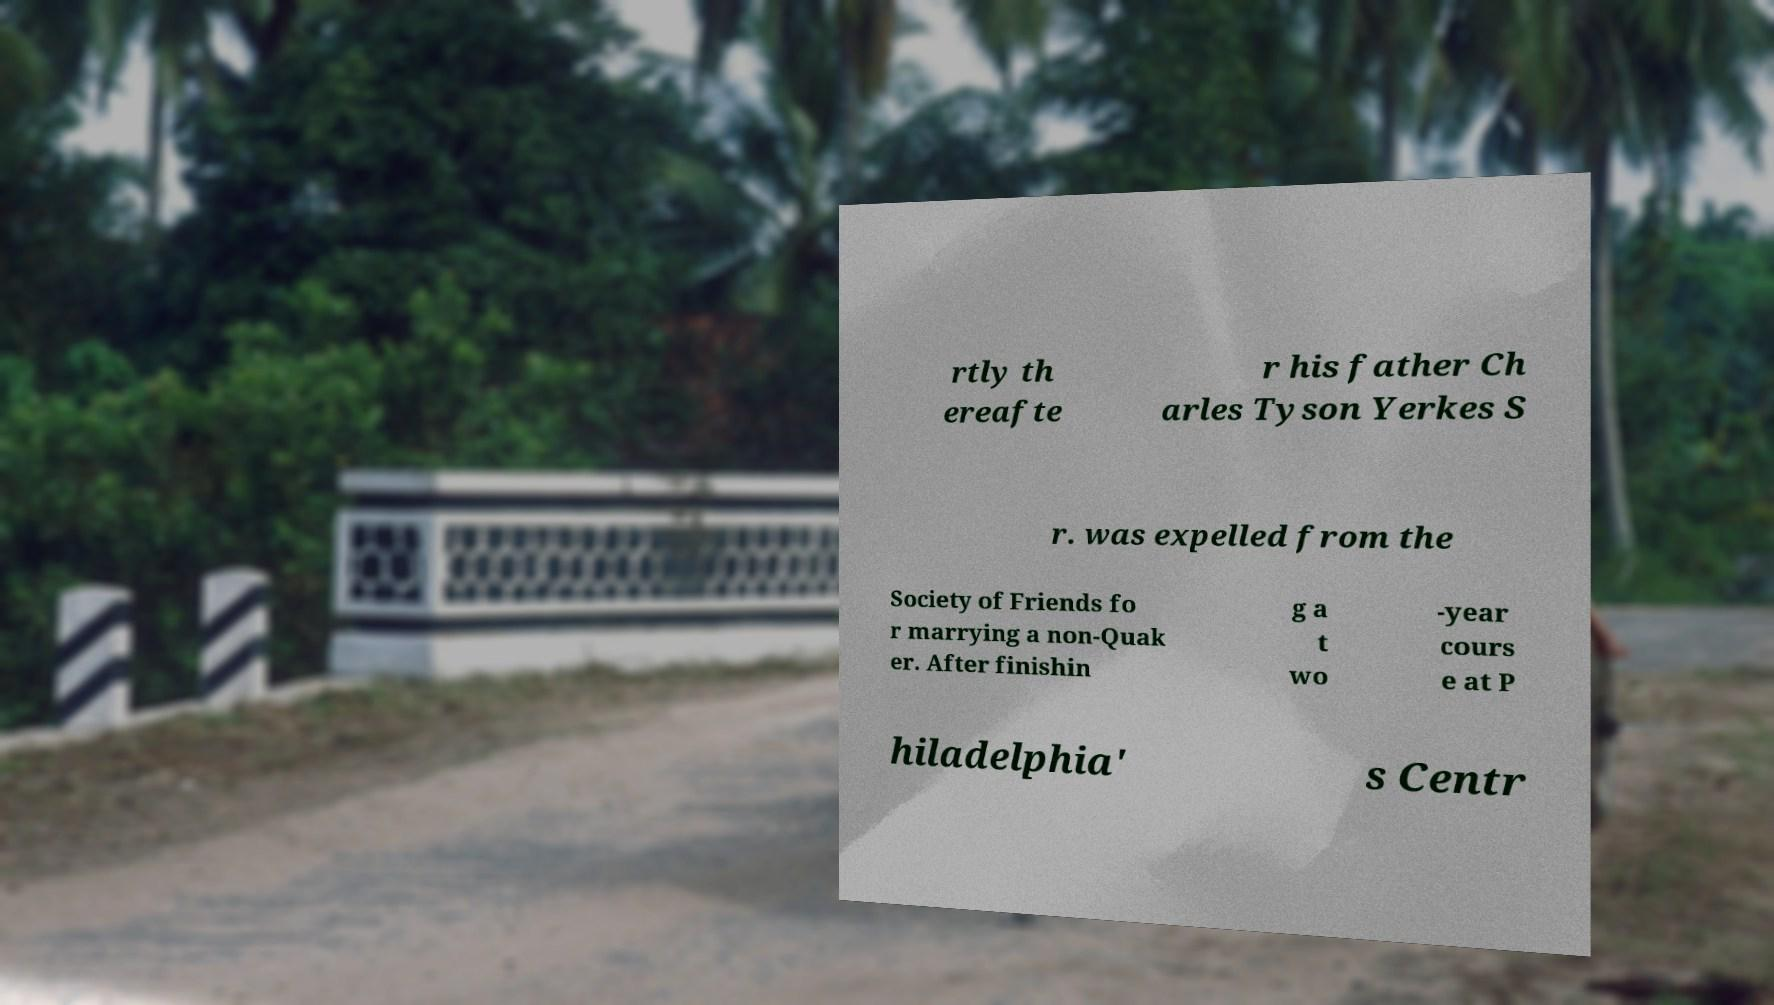I need the written content from this picture converted into text. Can you do that? rtly th ereafte r his father Ch arles Tyson Yerkes S r. was expelled from the Society of Friends fo r marrying a non-Quak er. After finishin g a t wo -year cours e at P hiladelphia' s Centr 